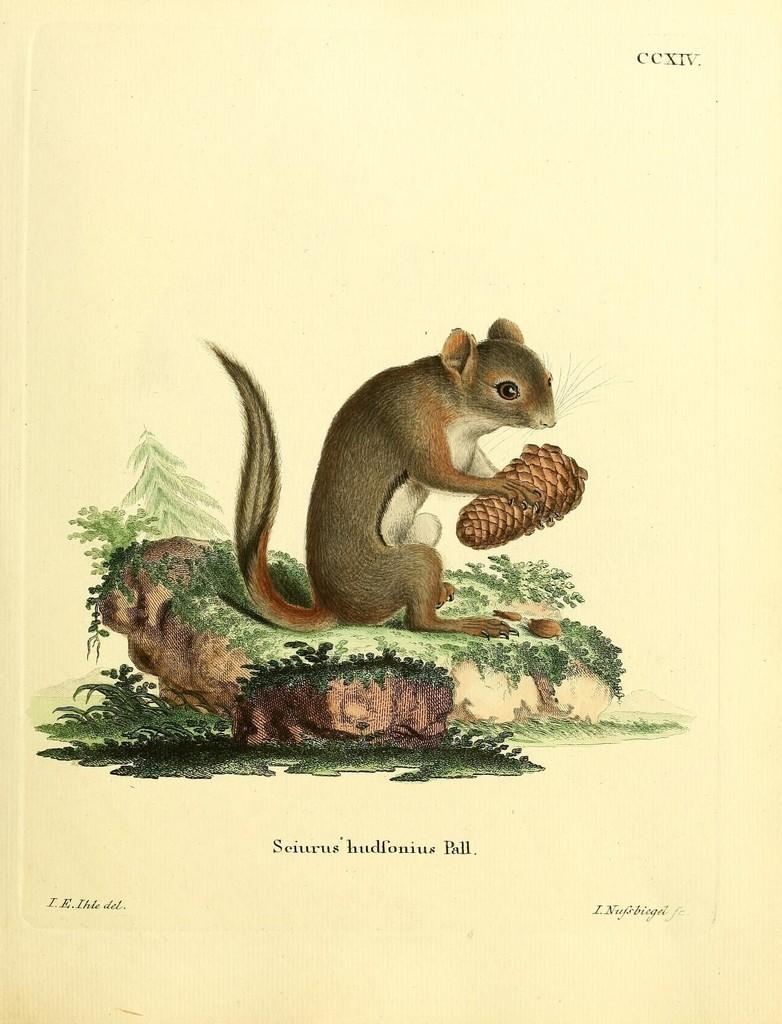What type of visual content is depicted in the image? The image is a poster. What animal can be seen in the poster? There is a squirrel in the image. What type of farm animals can be seen in the image? There are no farm animals present in the image; it features a squirrel. What type of peace is depicted in the image? There is no depiction of peace in the image; it features a squirrel. 